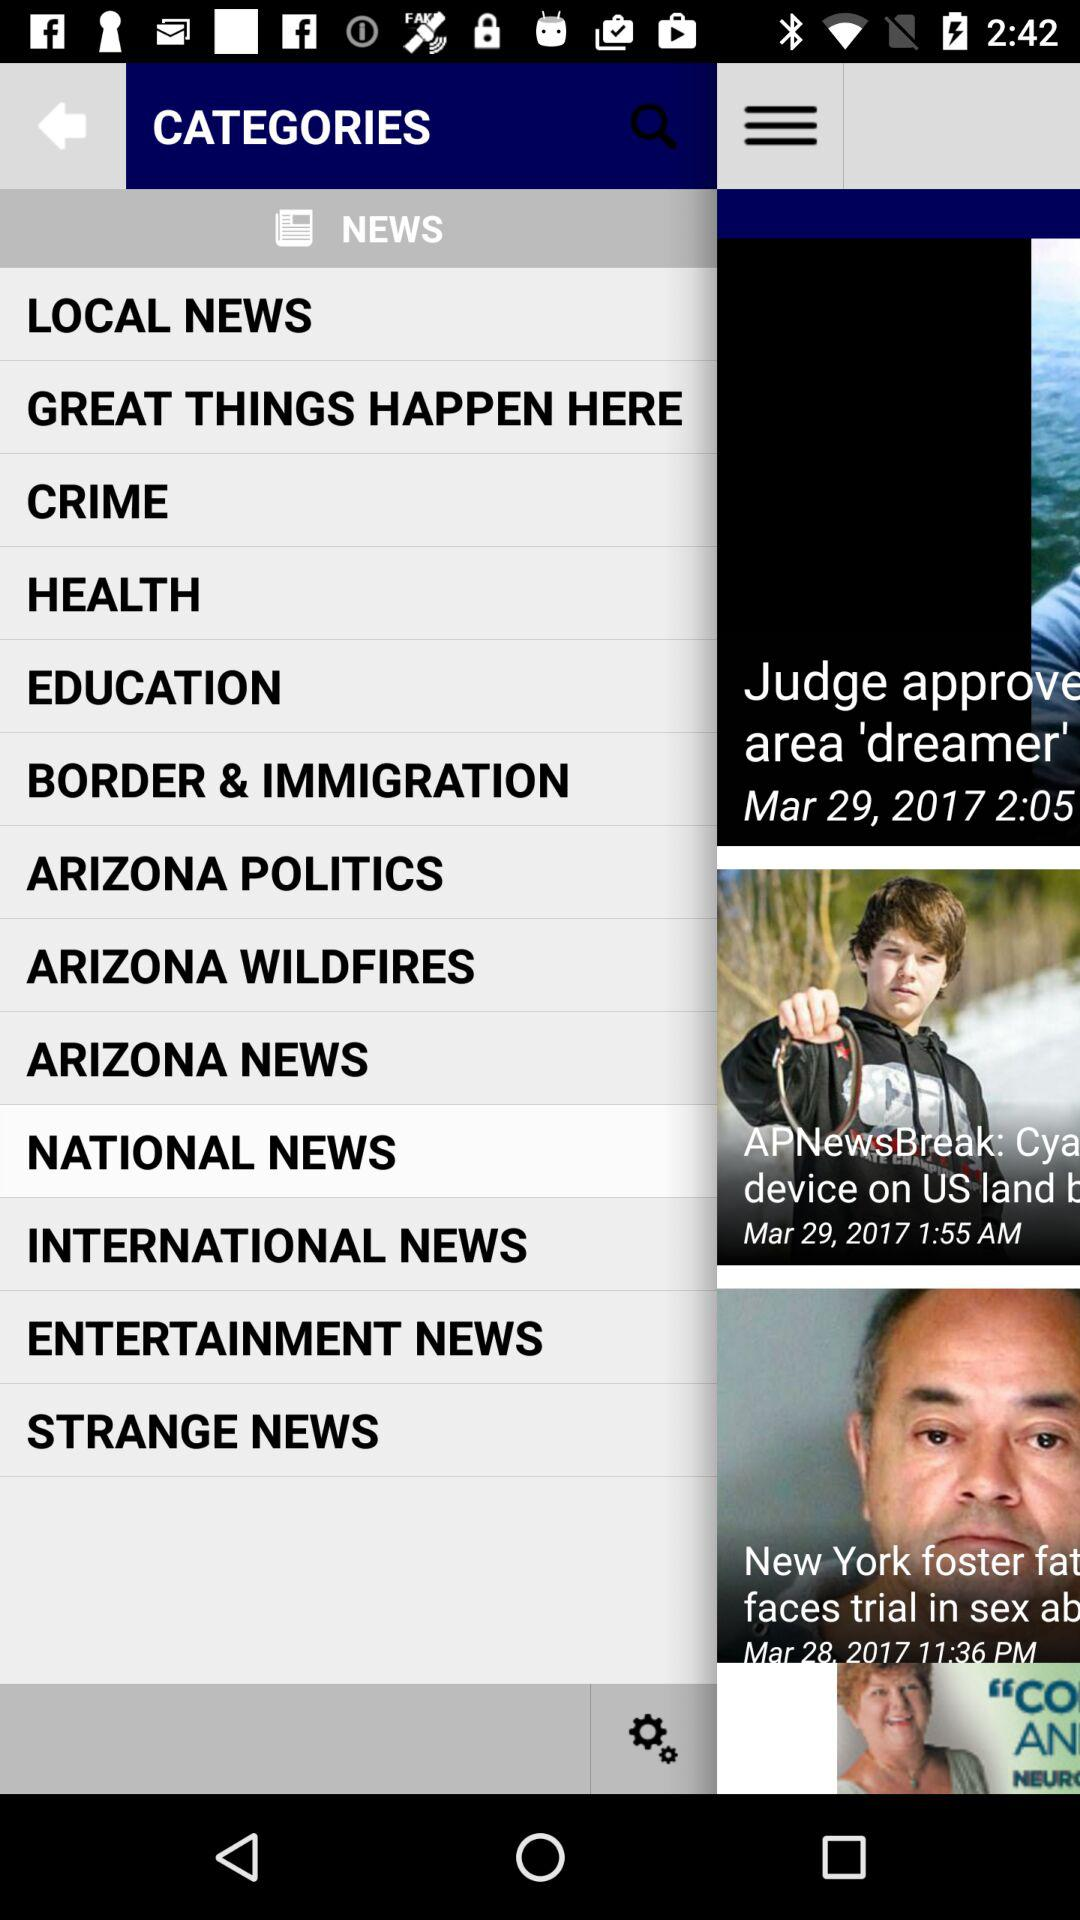Which item is currently selected? The currently selected item is "NATIONAL NEWS". 